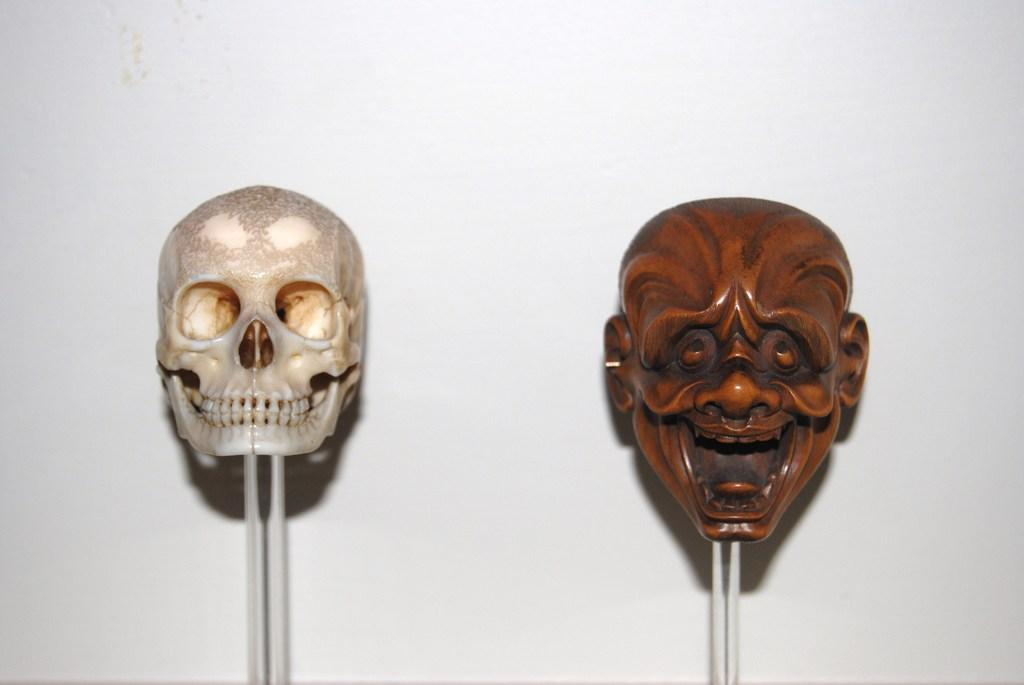What type of face statues can be seen in the image? There are two face statues in the image. Can you describe one of the face statues? One of the face statues is a skull. How are the face statues positioned in the image? The face statues are placed on poles. Can you hear the monkey crying in the image? There is no monkey present in the image, and therefore no crying can be heard. 